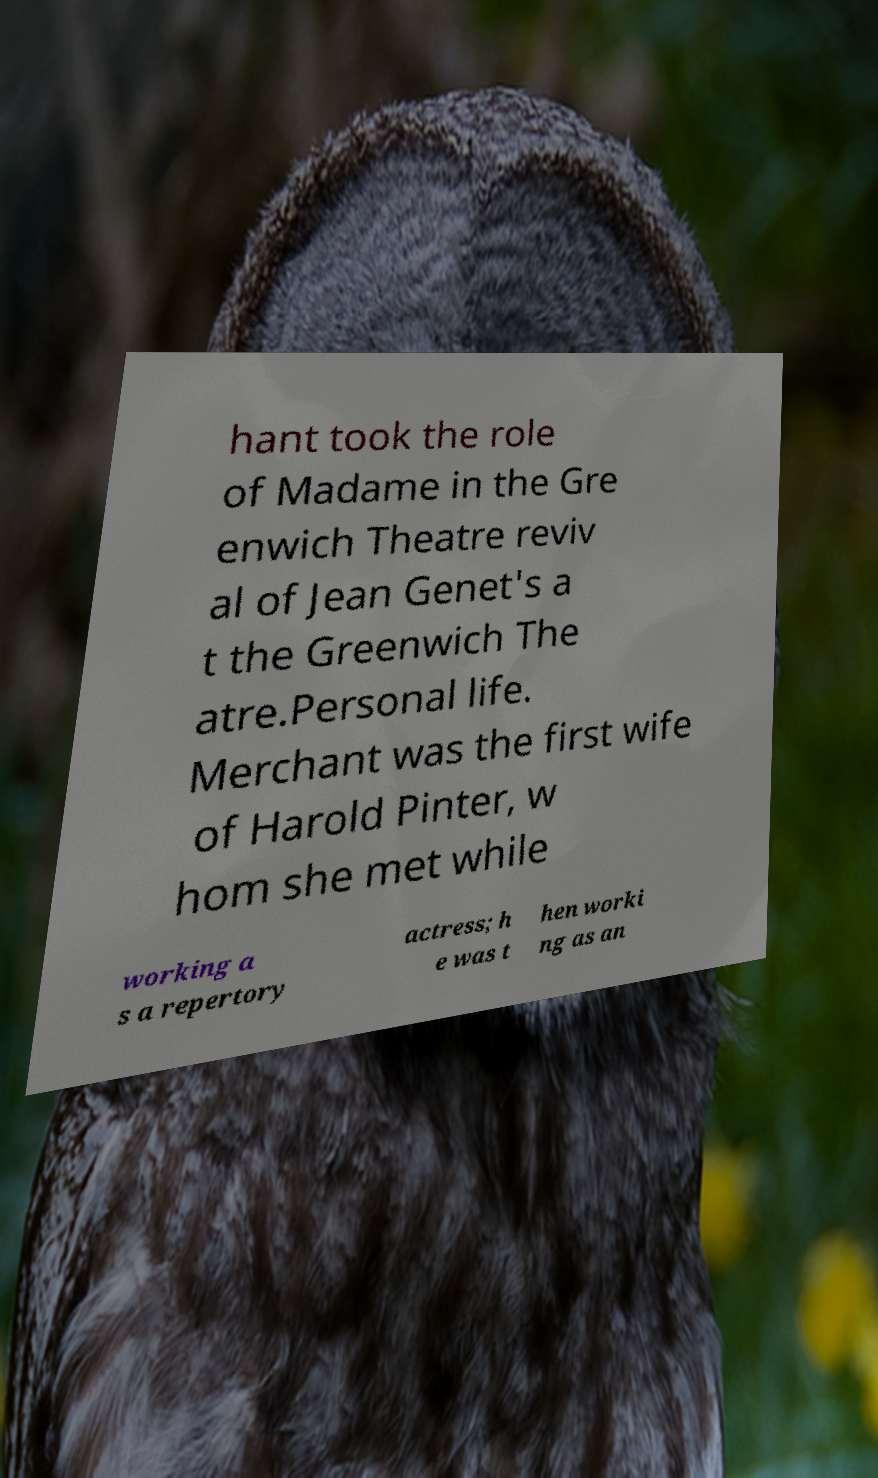Can you read and provide the text displayed in the image?This photo seems to have some interesting text. Can you extract and type it out for me? hant took the role of Madame in the Gre enwich Theatre reviv al of Jean Genet's a t the Greenwich The atre.Personal life. Merchant was the first wife of Harold Pinter, w hom she met while working a s a repertory actress; h e was t hen worki ng as an 